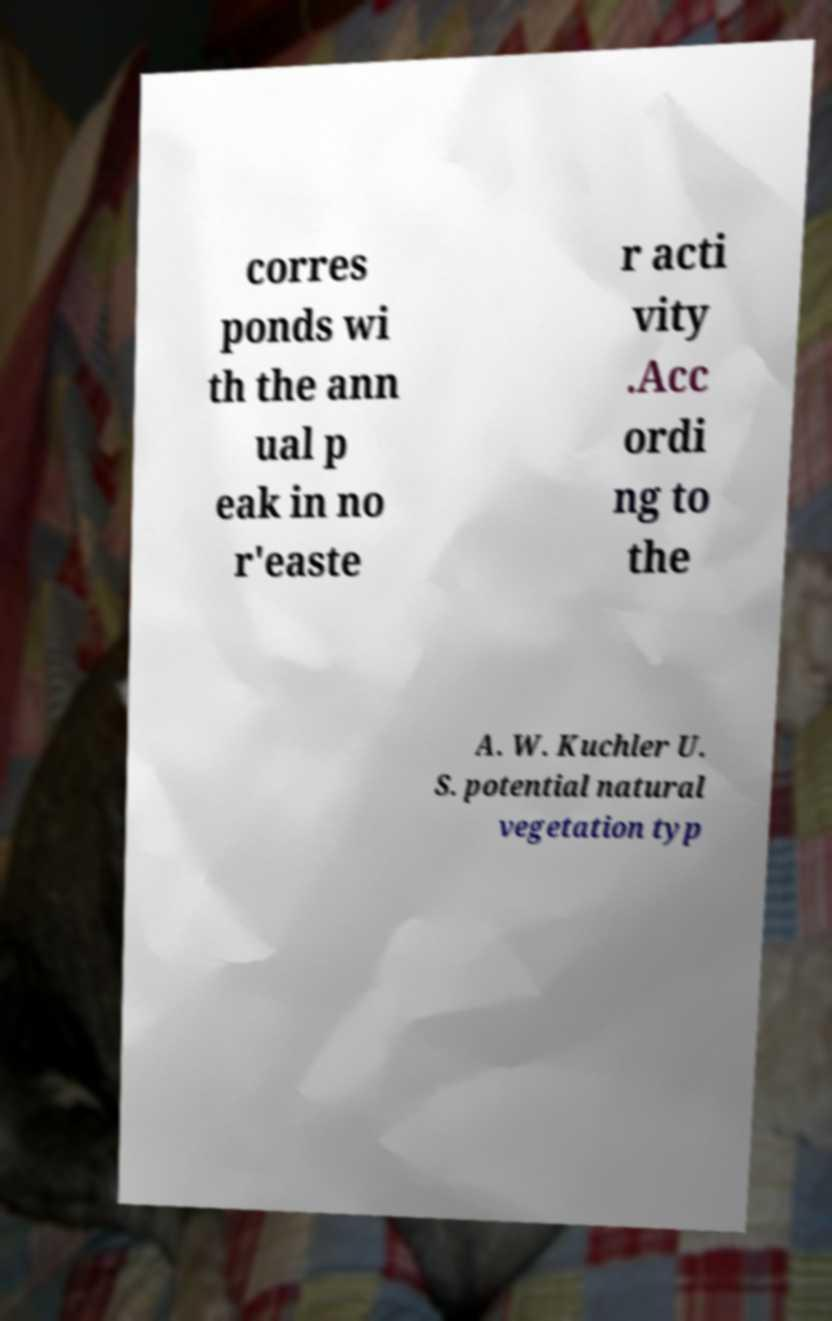Please read and relay the text visible in this image. What does it say? corres ponds wi th the ann ual p eak in no r'easte r acti vity .Acc ordi ng to the A. W. Kuchler U. S. potential natural vegetation typ 